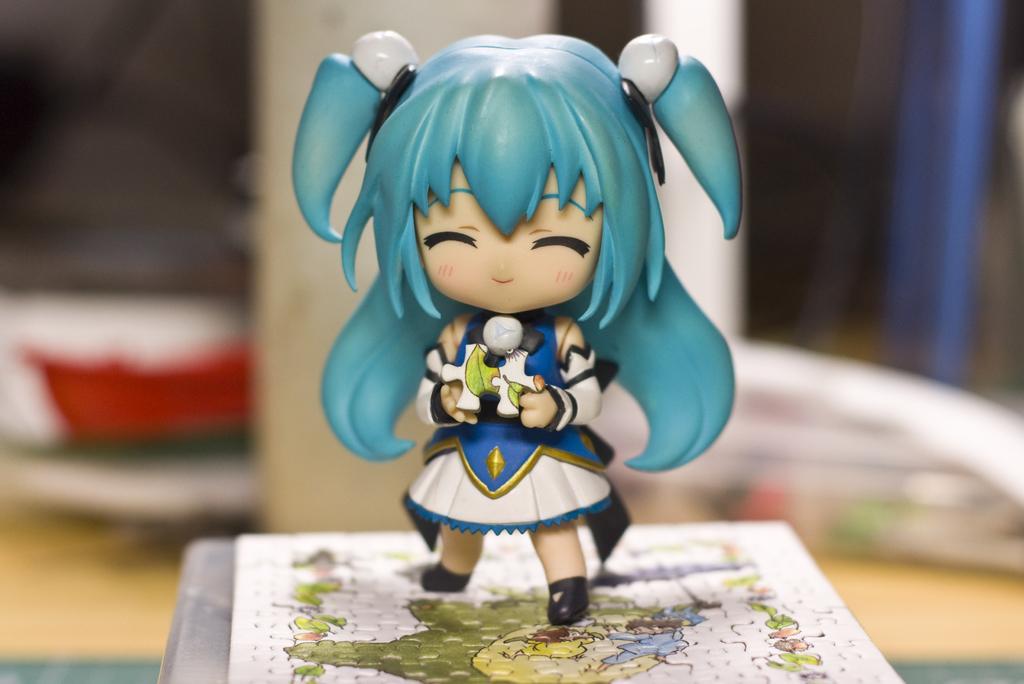In one or two sentences, can you explain what this image depicts? In this image there is a girl you standing on a jigsaw puzzle. The toy is holding a jigsaw puzzle piece. Behind the toy it is blurry. 